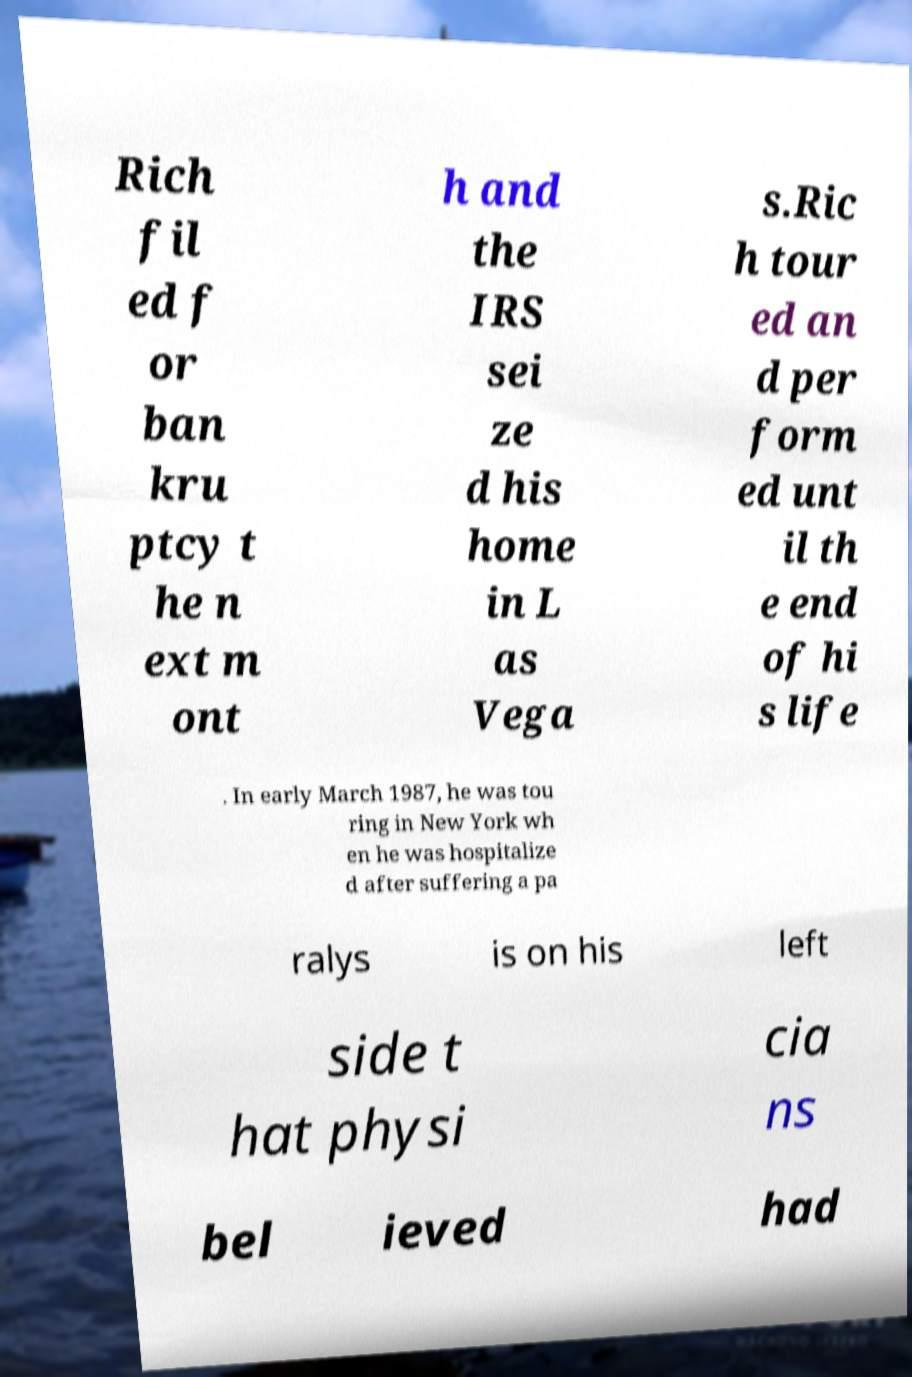What messages or text are displayed in this image? I need them in a readable, typed format. Rich fil ed f or ban kru ptcy t he n ext m ont h and the IRS sei ze d his home in L as Vega s.Ric h tour ed an d per form ed unt il th e end of hi s life . In early March 1987, he was tou ring in New York wh en he was hospitalize d after suffering a pa ralys is on his left side t hat physi cia ns bel ieved had 